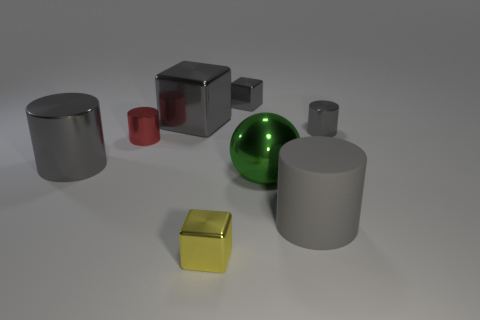Subtract all gray spheres. How many gray cylinders are left? 3 Subtract 1 cylinders. How many cylinders are left? 3 Subtract all purple cylinders. Subtract all red balls. How many cylinders are left? 4 Add 2 gray matte objects. How many objects exist? 10 Subtract all spheres. How many objects are left? 7 Add 3 red shiny cylinders. How many red shiny cylinders are left? 4 Add 2 shiny objects. How many shiny objects exist? 9 Subtract 0 yellow spheres. How many objects are left? 8 Subtract all large blue objects. Subtract all yellow blocks. How many objects are left? 7 